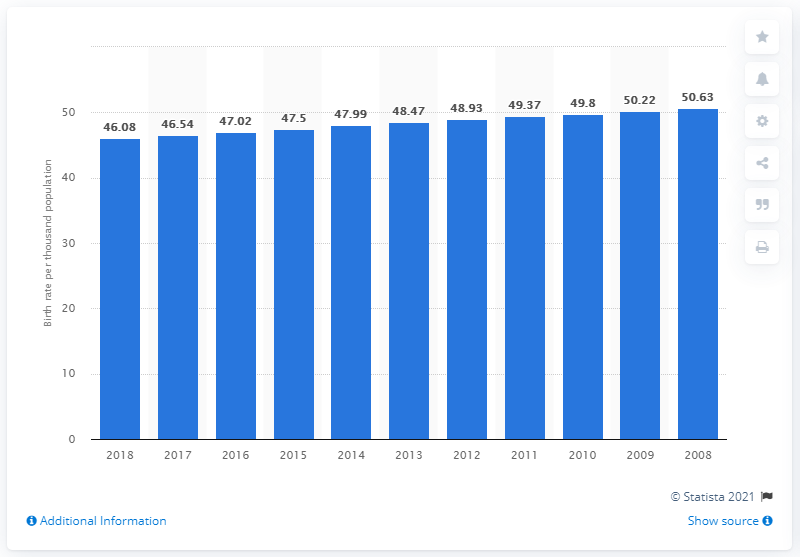Specify some key components in this picture. In 2018, the crude birth rate in Niger was 46.08. 